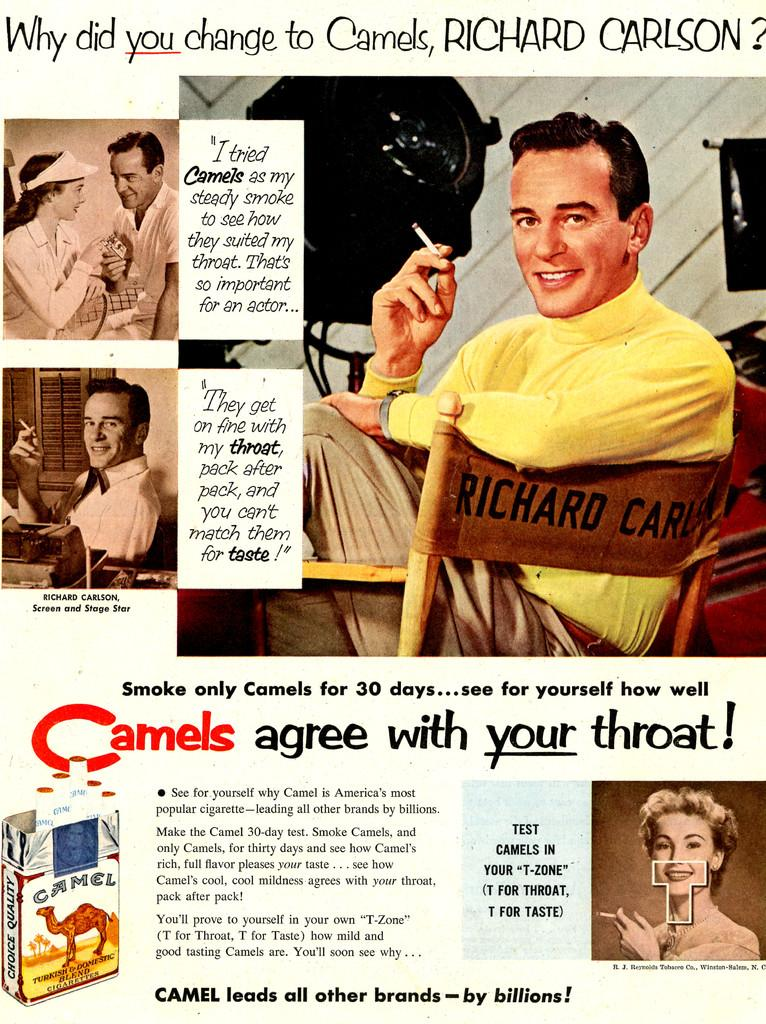Provide a one-sentence caption for the provided image. A retro advertisement featuring Richard carlson for Camel brand cigarettes. 